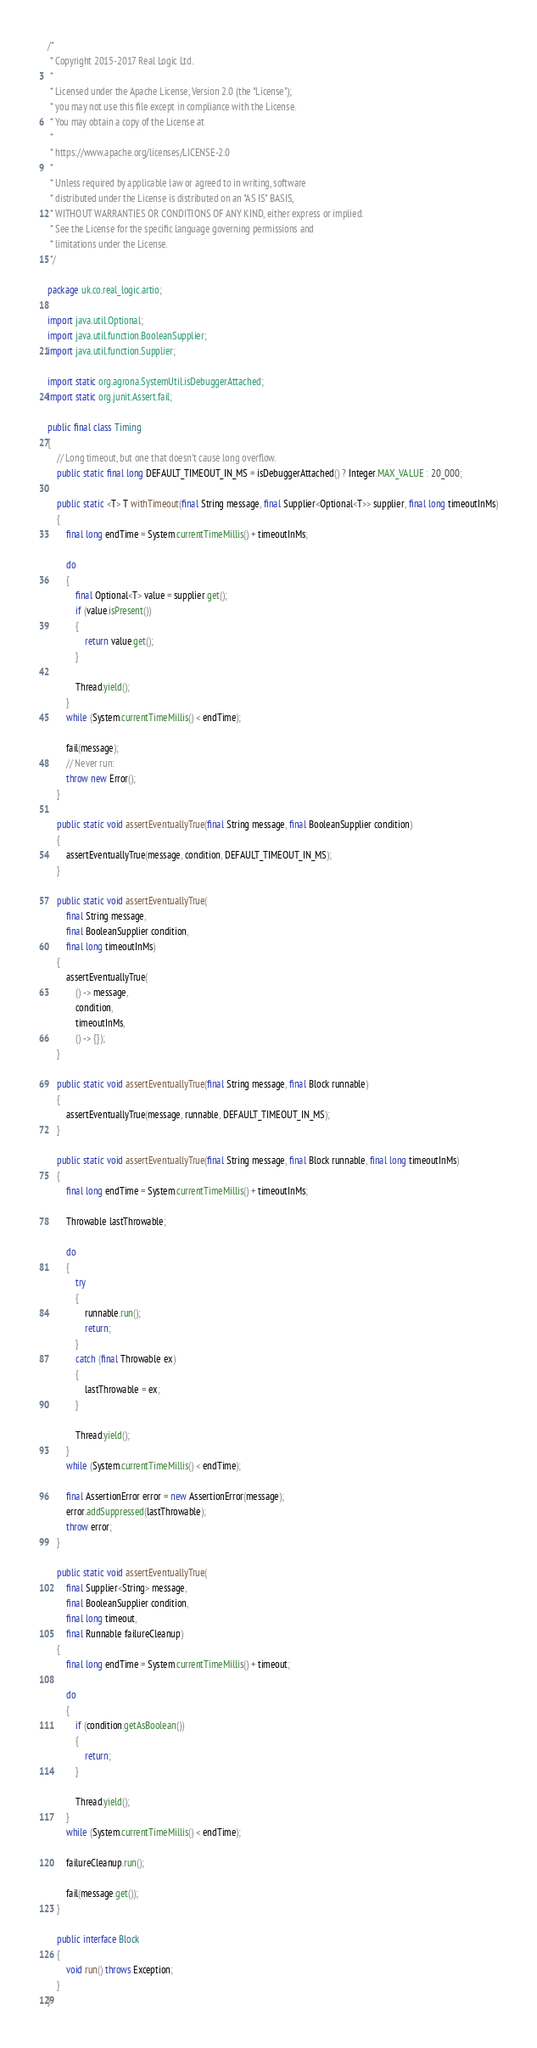Convert code to text. <code><loc_0><loc_0><loc_500><loc_500><_Java_>/*
 * Copyright 2015-2017 Real Logic Ltd.
 *
 * Licensed under the Apache License, Version 2.0 (the "License");
 * you may not use this file except in compliance with the License.
 * You may obtain a copy of the License at
 *
 * https://www.apache.org/licenses/LICENSE-2.0
 *
 * Unless required by applicable law or agreed to in writing, software
 * distributed under the License is distributed on an "AS IS" BASIS,
 * WITHOUT WARRANTIES OR CONDITIONS OF ANY KIND, either express or implied.
 * See the License for the specific language governing permissions and
 * limitations under the License.
 */

package uk.co.real_logic.artio;

import java.util.Optional;
import java.util.function.BooleanSupplier;
import java.util.function.Supplier;

import static org.agrona.SystemUtil.isDebuggerAttached;
import static org.junit.Assert.fail;

public final class Timing
{
    // Long timeout, but one that doesn't cause long overflow.
    public static final long DEFAULT_TIMEOUT_IN_MS = isDebuggerAttached() ? Integer.MAX_VALUE : 20_000;

    public static <T> T withTimeout(final String message, final Supplier<Optional<T>> supplier, final long timeoutInMs)
    {
        final long endTime = System.currentTimeMillis() + timeoutInMs;

        do
        {
            final Optional<T> value = supplier.get();
            if (value.isPresent())
            {
                return value.get();
            }

            Thread.yield();
        }
        while (System.currentTimeMillis() < endTime);

        fail(message);
        // Never run:
        throw new Error();
    }

    public static void assertEventuallyTrue(final String message, final BooleanSupplier condition)
    {
        assertEventuallyTrue(message, condition, DEFAULT_TIMEOUT_IN_MS);
    }

    public static void assertEventuallyTrue(
        final String message,
        final BooleanSupplier condition,
        final long timeoutInMs)
    {
        assertEventuallyTrue(
            () -> message,
            condition,
            timeoutInMs,
            () -> {});
    }

    public static void assertEventuallyTrue(final String message, final Block runnable)
    {
        assertEventuallyTrue(message, runnable, DEFAULT_TIMEOUT_IN_MS);
    }

    public static void assertEventuallyTrue(final String message, final Block runnable, final long timeoutInMs)
    {
        final long endTime = System.currentTimeMillis() + timeoutInMs;

        Throwable lastThrowable;

        do
        {
            try
            {
                runnable.run();
                return;
            }
            catch (final Throwable ex)
            {
                lastThrowable = ex;
            }

            Thread.yield();
        }
        while (System.currentTimeMillis() < endTime);

        final AssertionError error = new AssertionError(message);
        error.addSuppressed(lastThrowable);
        throw error;
    }

    public static void assertEventuallyTrue(
        final Supplier<String> message,
        final BooleanSupplier condition,
        final long timeout,
        final Runnable failureCleanup)
    {
        final long endTime = System.currentTimeMillis() + timeout;

        do
        {
            if (condition.getAsBoolean())
            {
                return;
            }

            Thread.yield();
        }
        while (System.currentTimeMillis() < endTime);

        failureCleanup.run();

        fail(message.get());
    }

    public interface Block
    {
        void run() throws Exception;
    }
}
</code> 